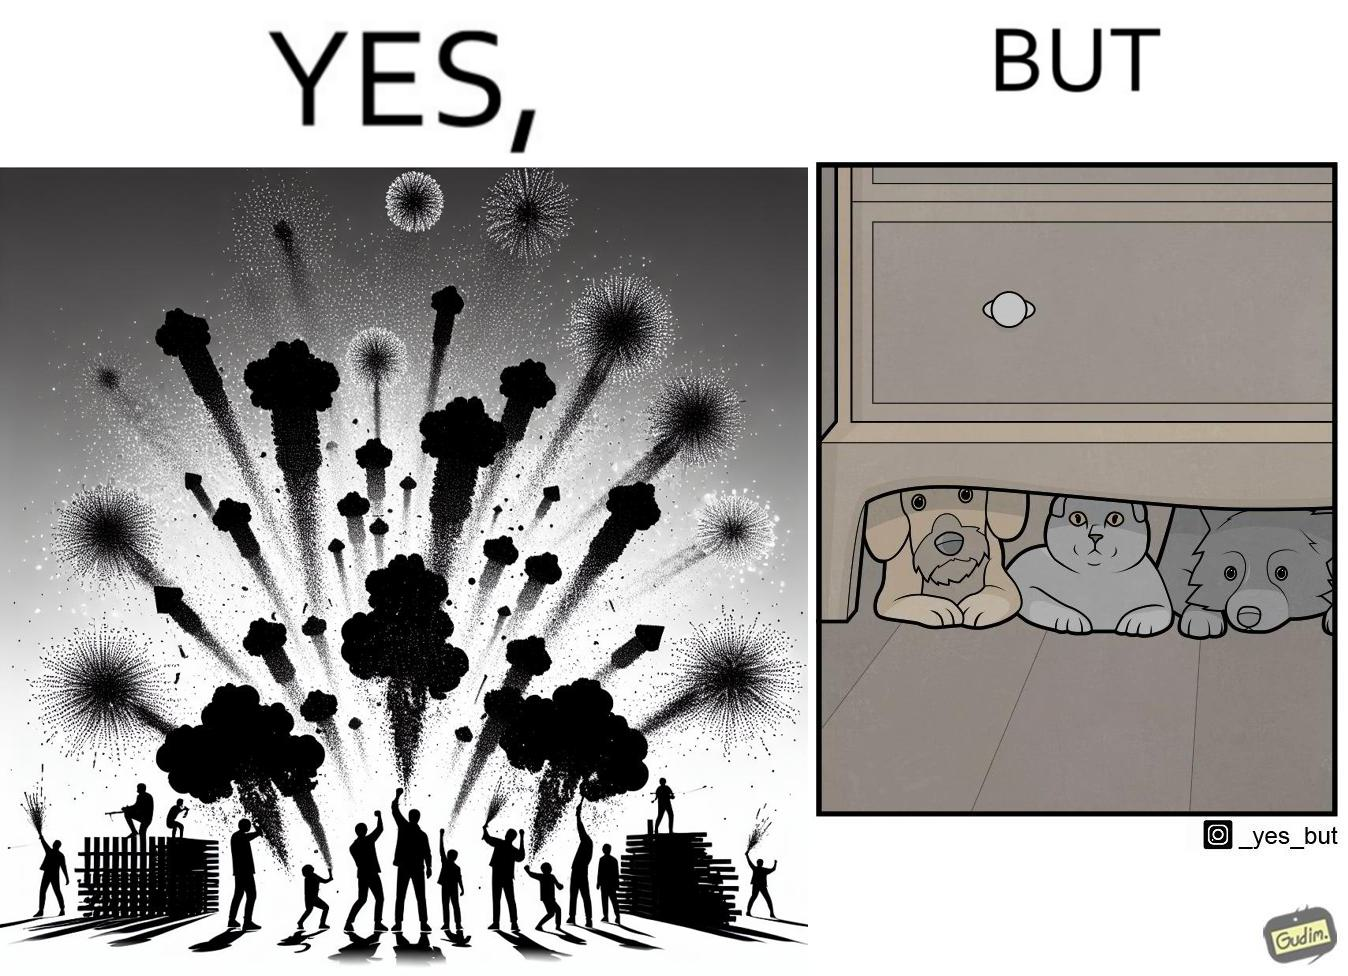Describe the contrast between the left and right parts of this image. In the left part of the image: The image shows colorful firecrackers going off in the sky. In the right part of the image: The image shows two dogs and a cat hiding under furniture. 